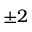<formula> <loc_0><loc_0><loc_500><loc_500>\pm 2</formula> 